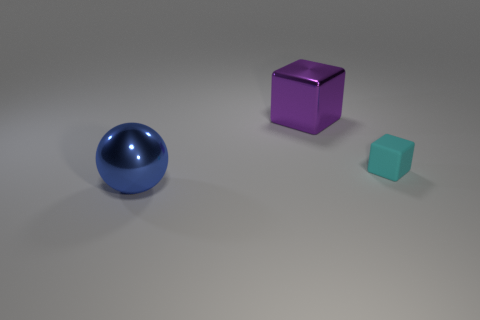Subtract all blocks. How many objects are left? 1 Subtract 2 cubes. How many cubes are left? 0 Add 3 tiny matte blocks. How many objects exist? 6 Add 3 cyan cubes. How many cyan cubes are left? 4 Add 2 yellow cylinders. How many yellow cylinders exist? 2 Subtract 0 red blocks. How many objects are left? 3 Subtract all green cubes. Subtract all purple cylinders. How many cubes are left? 2 Subtract all blue cylinders. How many blue blocks are left? 0 Subtract all small brown rubber spheres. Subtract all small cyan things. How many objects are left? 2 